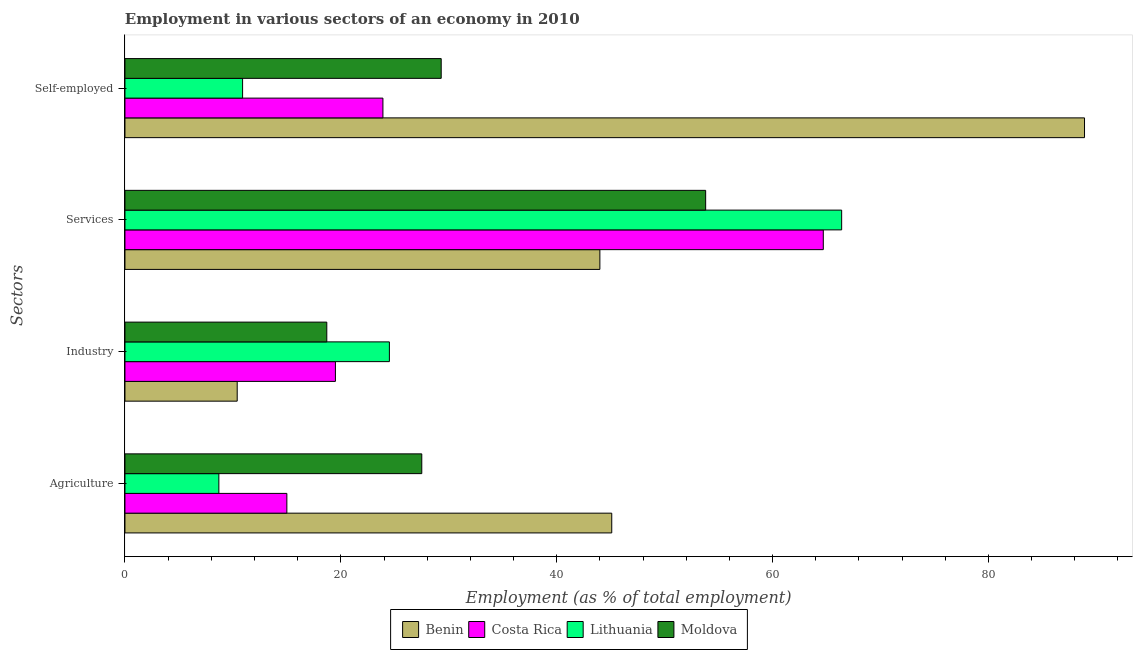How many groups of bars are there?
Offer a terse response. 4. How many bars are there on the 4th tick from the top?
Offer a terse response. 4. How many bars are there on the 1st tick from the bottom?
Make the answer very short. 4. What is the label of the 2nd group of bars from the top?
Provide a succinct answer. Services. What is the percentage of self employed workers in Moldova?
Give a very brief answer. 29.3. Across all countries, what is the maximum percentage of workers in services?
Offer a very short reply. 66.4. Across all countries, what is the minimum percentage of workers in agriculture?
Provide a succinct answer. 8.7. In which country was the percentage of workers in industry maximum?
Give a very brief answer. Lithuania. In which country was the percentage of workers in industry minimum?
Your answer should be compact. Benin. What is the total percentage of self employed workers in the graph?
Ensure brevity in your answer.  153. What is the difference between the percentage of workers in agriculture in Lithuania and that in Costa Rica?
Keep it short and to the point. -6.3. What is the difference between the percentage of workers in agriculture in Lithuania and the percentage of self employed workers in Costa Rica?
Offer a very short reply. -15.2. What is the average percentage of self employed workers per country?
Provide a succinct answer. 38.25. What is the difference between the percentage of self employed workers and percentage of workers in services in Lithuania?
Ensure brevity in your answer.  -55.5. In how many countries, is the percentage of workers in industry greater than 24 %?
Give a very brief answer. 1. What is the ratio of the percentage of self employed workers in Moldova to that in Lithuania?
Make the answer very short. 2.69. Is the percentage of workers in agriculture in Lithuania less than that in Costa Rica?
Give a very brief answer. Yes. What is the difference between the highest and the second highest percentage of workers in agriculture?
Your answer should be very brief. 17.6. What is the difference between the highest and the lowest percentage of workers in agriculture?
Your answer should be very brief. 36.4. What does the 1st bar from the top in Services represents?
Provide a succinct answer. Moldova. What does the 3rd bar from the bottom in Industry represents?
Your answer should be very brief. Lithuania. Are all the bars in the graph horizontal?
Keep it short and to the point. Yes. What is the difference between two consecutive major ticks on the X-axis?
Your answer should be compact. 20. How many legend labels are there?
Offer a terse response. 4. What is the title of the graph?
Keep it short and to the point. Employment in various sectors of an economy in 2010. Does "Antigua and Barbuda" appear as one of the legend labels in the graph?
Offer a terse response. No. What is the label or title of the X-axis?
Your answer should be compact. Employment (as % of total employment). What is the label or title of the Y-axis?
Keep it short and to the point. Sectors. What is the Employment (as % of total employment) of Benin in Agriculture?
Provide a short and direct response. 45.1. What is the Employment (as % of total employment) in Lithuania in Agriculture?
Your answer should be compact. 8.7. What is the Employment (as % of total employment) in Moldova in Agriculture?
Give a very brief answer. 27.5. What is the Employment (as % of total employment) in Benin in Industry?
Your answer should be very brief. 10.4. What is the Employment (as % of total employment) in Costa Rica in Industry?
Give a very brief answer. 19.5. What is the Employment (as % of total employment) of Lithuania in Industry?
Ensure brevity in your answer.  24.5. What is the Employment (as % of total employment) in Moldova in Industry?
Give a very brief answer. 18.7. What is the Employment (as % of total employment) in Costa Rica in Services?
Ensure brevity in your answer.  64.7. What is the Employment (as % of total employment) in Lithuania in Services?
Offer a very short reply. 66.4. What is the Employment (as % of total employment) in Moldova in Services?
Your answer should be very brief. 53.8. What is the Employment (as % of total employment) of Benin in Self-employed?
Provide a succinct answer. 88.9. What is the Employment (as % of total employment) in Costa Rica in Self-employed?
Offer a terse response. 23.9. What is the Employment (as % of total employment) in Lithuania in Self-employed?
Offer a very short reply. 10.9. What is the Employment (as % of total employment) of Moldova in Self-employed?
Keep it short and to the point. 29.3. Across all Sectors, what is the maximum Employment (as % of total employment) in Benin?
Make the answer very short. 88.9. Across all Sectors, what is the maximum Employment (as % of total employment) of Costa Rica?
Offer a very short reply. 64.7. Across all Sectors, what is the maximum Employment (as % of total employment) of Lithuania?
Make the answer very short. 66.4. Across all Sectors, what is the maximum Employment (as % of total employment) of Moldova?
Your answer should be very brief. 53.8. Across all Sectors, what is the minimum Employment (as % of total employment) in Benin?
Make the answer very short. 10.4. Across all Sectors, what is the minimum Employment (as % of total employment) of Costa Rica?
Keep it short and to the point. 15. Across all Sectors, what is the minimum Employment (as % of total employment) of Lithuania?
Your answer should be very brief. 8.7. Across all Sectors, what is the minimum Employment (as % of total employment) in Moldova?
Keep it short and to the point. 18.7. What is the total Employment (as % of total employment) in Benin in the graph?
Provide a short and direct response. 188.4. What is the total Employment (as % of total employment) in Costa Rica in the graph?
Your answer should be compact. 123.1. What is the total Employment (as % of total employment) in Lithuania in the graph?
Provide a short and direct response. 110.5. What is the total Employment (as % of total employment) of Moldova in the graph?
Your response must be concise. 129.3. What is the difference between the Employment (as % of total employment) of Benin in Agriculture and that in Industry?
Ensure brevity in your answer.  34.7. What is the difference between the Employment (as % of total employment) in Costa Rica in Agriculture and that in Industry?
Your answer should be compact. -4.5. What is the difference between the Employment (as % of total employment) of Lithuania in Agriculture and that in Industry?
Give a very brief answer. -15.8. What is the difference between the Employment (as % of total employment) of Moldova in Agriculture and that in Industry?
Ensure brevity in your answer.  8.8. What is the difference between the Employment (as % of total employment) in Costa Rica in Agriculture and that in Services?
Your answer should be compact. -49.7. What is the difference between the Employment (as % of total employment) in Lithuania in Agriculture and that in Services?
Provide a short and direct response. -57.7. What is the difference between the Employment (as % of total employment) in Moldova in Agriculture and that in Services?
Offer a terse response. -26.3. What is the difference between the Employment (as % of total employment) of Benin in Agriculture and that in Self-employed?
Make the answer very short. -43.8. What is the difference between the Employment (as % of total employment) in Costa Rica in Agriculture and that in Self-employed?
Offer a terse response. -8.9. What is the difference between the Employment (as % of total employment) in Benin in Industry and that in Services?
Ensure brevity in your answer.  -33.6. What is the difference between the Employment (as % of total employment) of Costa Rica in Industry and that in Services?
Provide a short and direct response. -45.2. What is the difference between the Employment (as % of total employment) in Lithuania in Industry and that in Services?
Ensure brevity in your answer.  -41.9. What is the difference between the Employment (as % of total employment) in Moldova in Industry and that in Services?
Your answer should be very brief. -35.1. What is the difference between the Employment (as % of total employment) of Benin in Industry and that in Self-employed?
Provide a short and direct response. -78.5. What is the difference between the Employment (as % of total employment) of Moldova in Industry and that in Self-employed?
Your answer should be very brief. -10.6. What is the difference between the Employment (as % of total employment) of Benin in Services and that in Self-employed?
Your answer should be compact. -44.9. What is the difference between the Employment (as % of total employment) of Costa Rica in Services and that in Self-employed?
Offer a terse response. 40.8. What is the difference between the Employment (as % of total employment) of Lithuania in Services and that in Self-employed?
Your response must be concise. 55.5. What is the difference between the Employment (as % of total employment) in Benin in Agriculture and the Employment (as % of total employment) in Costa Rica in Industry?
Give a very brief answer. 25.6. What is the difference between the Employment (as % of total employment) of Benin in Agriculture and the Employment (as % of total employment) of Lithuania in Industry?
Provide a short and direct response. 20.6. What is the difference between the Employment (as % of total employment) in Benin in Agriculture and the Employment (as % of total employment) in Moldova in Industry?
Provide a succinct answer. 26.4. What is the difference between the Employment (as % of total employment) of Costa Rica in Agriculture and the Employment (as % of total employment) of Moldova in Industry?
Your answer should be compact. -3.7. What is the difference between the Employment (as % of total employment) of Benin in Agriculture and the Employment (as % of total employment) of Costa Rica in Services?
Make the answer very short. -19.6. What is the difference between the Employment (as % of total employment) of Benin in Agriculture and the Employment (as % of total employment) of Lithuania in Services?
Provide a succinct answer. -21.3. What is the difference between the Employment (as % of total employment) in Costa Rica in Agriculture and the Employment (as % of total employment) in Lithuania in Services?
Provide a succinct answer. -51.4. What is the difference between the Employment (as % of total employment) in Costa Rica in Agriculture and the Employment (as % of total employment) in Moldova in Services?
Offer a very short reply. -38.8. What is the difference between the Employment (as % of total employment) in Lithuania in Agriculture and the Employment (as % of total employment) in Moldova in Services?
Offer a terse response. -45.1. What is the difference between the Employment (as % of total employment) in Benin in Agriculture and the Employment (as % of total employment) in Costa Rica in Self-employed?
Provide a succinct answer. 21.2. What is the difference between the Employment (as % of total employment) in Benin in Agriculture and the Employment (as % of total employment) in Lithuania in Self-employed?
Offer a very short reply. 34.2. What is the difference between the Employment (as % of total employment) in Costa Rica in Agriculture and the Employment (as % of total employment) in Lithuania in Self-employed?
Your answer should be very brief. 4.1. What is the difference between the Employment (as % of total employment) in Costa Rica in Agriculture and the Employment (as % of total employment) in Moldova in Self-employed?
Give a very brief answer. -14.3. What is the difference between the Employment (as % of total employment) of Lithuania in Agriculture and the Employment (as % of total employment) of Moldova in Self-employed?
Provide a succinct answer. -20.6. What is the difference between the Employment (as % of total employment) of Benin in Industry and the Employment (as % of total employment) of Costa Rica in Services?
Offer a terse response. -54.3. What is the difference between the Employment (as % of total employment) of Benin in Industry and the Employment (as % of total employment) of Lithuania in Services?
Provide a short and direct response. -56. What is the difference between the Employment (as % of total employment) of Benin in Industry and the Employment (as % of total employment) of Moldova in Services?
Offer a terse response. -43.4. What is the difference between the Employment (as % of total employment) of Costa Rica in Industry and the Employment (as % of total employment) of Lithuania in Services?
Your answer should be very brief. -46.9. What is the difference between the Employment (as % of total employment) of Costa Rica in Industry and the Employment (as % of total employment) of Moldova in Services?
Give a very brief answer. -34.3. What is the difference between the Employment (as % of total employment) of Lithuania in Industry and the Employment (as % of total employment) of Moldova in Services?
Your answer should be very brief. -29.3. What is the difference between the Employment (as % of total employment) in Benin in Industry and the Employment (as % of total employment) in Costa Rica in Self-employed?
Offer a very short reply. -13.5. What is the difference between the Employment (as % of total employment) of Benin in Industry and the Employment (as % of total employment) of Lithuania in Self-employed?
Offer a terse response. -0.5. What is the difference between the Employment (as % of total employment) in Benin in Industry and the Employment (as % of total employment) in Moldova in Self-employed?
Your answer should be very brief. -18.9. What is the difference between the Employment (as % of total employment) of Costa Rica in Industry and the Employment (as % of total employment) of Lithuania in Self-employed?
Your answer should be very brief. 8.6. What is the difference between the Employment (as % of total employment) of Costa Rica in Industry and the Employment (as % of total employment) of Moldova in Self-employed?
Your answer should be very brief. -9.8. What is the difference between the Employment (as % of total employment) of Benin in Services and the Employment (as % of total employment) of Costa Rica in Self-employed?
Your answer should be compact. 20.1. What is the difference between the Employment (as % of total employment) in Benin in Services and the Employment (as % of total employment) in Lithuania in Self-employed?
Your response must be concise. 33.1. What is the difference between the Employment (as % of total employment) of Costa Rica in Services and the Employment (as % of total employment) of Lithuania in Self-employed?
Offer a very short reply. 53.8. What is the difference between the Employment (as % of total employment) in Costa Rica in Services and the Employment (as % of total employment) in Moldova in Self-employed?
Your answer should be very brief. 35.4. What is the difference between the Employment (as % of total employment) in Lithuania in Services and the Employment (as % of total employment) in Moldova in Self-employed?
Ensure brevity in your answer.  37.1. What is the average Employment (as % of total employment) in Benin per Sectors?
Keep it short and to the point. 47.1. What is the average Employment (as % of total employment) of Costa Rica per Sectors?
Make the answer very short. 30.77. What is the average Employment (as % of total employment) of Lithuania per Sectors?
Offer a terse response. 27.62. What is the average Employment (as % of total employment) in Moldova per Sectors?
Make the answer very short. 32.33. What is the difference between the Employment (as % of total employment) of Benin and Employment (as % of total employment) of Costa Rica in Agriculture?
Your response must be concise. 30.1. What is the difference between the Employment (as % of total employment) in Benin and Employment (as % of total employment) in Lithuania in Agriculture?
Your answer should be compact. 36.4. What is the difference between the Employment (as % of total employment) of Benin and Employment (as % of total employment) of Moldova in Agriculture?
Your response must be concise. 17.6. What is the difference between the Employment (as % of total employment) in Costa Rica and Employment (as % of total employment) in Moldova in Agriculture?
Offer a very short reply. -12.5. What is the difference between the Employment (as % of total employment) of Lithuania and Employment (as % of total employment) of Moldova in Agriculture?
Your response must be concise. -18.8. What is the difference between the Employment (as % of total employment) of Benin and Employment (as % of total employment) of Lithuania in Industry?
Give a very brief answer. -14.1. What is the difference between the Employment (as % of total employment) in Benin and Employment (as % of total employment) in Moldova in Industry?
Offer a terse response. -8.3. What is the difference between the Employment (as % of total employment) of Costa Rica and Employment (as % of total employment) of Moldova in Industry?
Ensure brevity in your answer.  0.8. What is the difference between the Employment (as % of total employment) of Lithuania and Employment (as % of total employment) of Moldova in Industry?
Provide a short and direct response. 5.8. What is the difference between the Employment (as % of total employment) of Benin and Employment (as % of total employment) of Costa Rica in Services?
Your response must be concise. -20.7. What is the difference between the Employment (as % of total employment) of Benin and Employment (as % of total employment) of Lithuania in Services?
Your response must be concise. -22.4. What is the difference between the Employment (as % of total employment) in Lithuania and Employment (as % of total employment) in Moldova in Services?
Your answer should be compact. 12.6. What is the difference between the Employment (as % of total employment) in Benin and Employment (as % of total employment) in Lithuania in Self-employed?
Your response must be concise. 78. What is the difference between the Employment (as % of total employment) in Benin and Employment (as % of total employment) in Moldova in Self-employed?
Provide a short and direct response. 59.6. What is the difference between the Employment (as % of total employment) of Costa Rica and Employment (as % of total employment) of Lithuania in Self-employed?
Keep it short and to the point. 13. What is the difference between the Employment (as % of total employment) of Lithuania and Employment (as % of total employment) of Moldova in Self-employed?
Give a very brief answer. -18.4. What is the ratio of the Employment (as % of total employment) in Benin in Agriculture to that in Industry?
Offer a very short reply. 4.34. What is the ratio of the Employment (as % of total employment) of Costa Rica in Agriculture to that in Industry?
Your answer should be compact. 0.77. What is the ratio of the Employment (as % of total employment) in Lithuania in Agriculture to that in Industry?
Your response must be concise. 0.36. What is the ratio of the Employment (as % of total employment) of Moldova in Agriculture to that in Industry?
Provide a succinct answer. 1.47. What is the ratio of the Employment (as % of total employment) in Benin in Agriculture to that in Services?
Ensure brevity in your answer.  1.02. What is the ratio of the Employment (as % of total employment) of Costa Rica in Agriculture to that in Services?
Offer a terse response. 0.23. What is the ratio of the Employment (as % of total employment) in Lithuania in Agriculture to that in Services?
Provide a succinct answer. 0.13. What is the ratio of the Employment (as % of total employment) in Moldova in Agriculture to that in Services?
Offer a very short reply. 0.51. What is the ratio of the Employment (as % of total employment) in Benin in Agriculture to that in Self-employed?
Offer a very short reply. 0.51. What is the ratio of the Employment (as % of total employment) of Costa Rica in Agriculture to that in Self-employed?
Make the answer very short. 0.63. What is the ratio of the Employment (as % of total employment) of Lithuania in Agriculture to that in Self-employed?
Offer a very short reply. 0.8. What is the ratio of the Employment (as % of total employment) in Moldova in Agriculture to that in Self-employed?
Give a very brief answer. 0.94. What is the ratio of the Employment (as % of total employment) in Benin in Industry to that in Services?
Your response must be concise. 0.24. What is the ratio of the Employment (as % of total employment) of Costa Rica in Industry to that in Services?
Make the answer very short. 0.3. What is the ratio of the Employment (as % of total employment) in Lithuania in Industry to that in Services?
Your answer should be very brief. 0.37. What is the ratio of the Employment (as % of total employment) in Moldova in Industry to that in Services?
Your answer should be compact. 0.35. What is the ratio of the Employment (as % of total employment) in Benin in Industry to that in Self-employed?
Your answer should be very brief. 0.12. What is the ratio of the Employment (as % of total employment) of Costa Rica in Industry to that in Self-employed?
Make the answer very short. 0.82. What is the ratio of the Employment (as % of total employment) of Lithuania in Industry to that in Self-employed?
Offer a very short reply. 2.25. What is the ratio of the Employment (as % of total employment) in Moldova in Industry to that in Self-employed?
Provide a short and direct response. 0.64. What is the ratio of the Employment (as % of total employment) in Benin in Services to that in Self-employed?
Provide a succinct answer. 0.49. What is the ratio of the Employment (as % of total employment) of Costa Rica in Services to that in Self-employed?
Provide a succinct answer. 2.71. What is the ratio of the Employment (as % of total employment) in Lithuania in Services to that in Self-employed?
Provide a succinct answer. 6.09. What is the ratio of the Employment (as % of total employment) of Moldova in Services to that in Self-employed?
Provide a succinct answer. 1.84. What is the difference between the highest and the second highest Employment (as % of total employment) in Benin?
Provide a succinct answer. 43.8. What is the difference between the highest and the second highest Employment (as % of total employment) of Costa Rica?
Provide a succinct answer. 40.8. What is the difference between the highest and the second highest Employment (as % of total employment) of Lithuania?
Make the answer very short. 41.9. What is the difference between the highest and the second highest Employment (as % of total employment) in Moldova?
Keep it short and to the point. 24.5. What is the difference between the highest and the lowest Employment (as % of total employment) in Benin?
Give a very brief answer. 78.5. What is the difference between the highest and the lowest Employment (as % of total employment) of Costa Rica?
Ensure brevity in your answer.  49.7. What is the difference between the highest and the lowest Employment (as % of total employment) of Lithuania?
Give a very brief answer. 57.7. What is the difference between the highest and the lowest Employment (as % of total employment) in Moldova?
Keep it short and to the point. 35.1. 